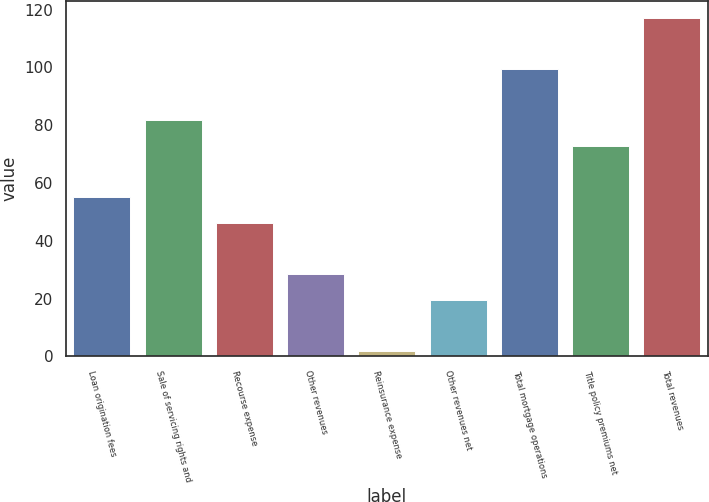<chart> <loc_0><loc_0><loc_500><loc_500><bar_chart><fcel>Loan origination fees<fcel>Sale of servicing rights and<fcel>Recourse expense<fcel>Other revenues<fcel>Reinsurance expense<fcel>Other revenues net<fcel>Total mortgage operations<fcel>Title policy premiums net<fcel>Total revenues<nl><fcel>55.06<fcel>81.64<fcel>46.2<fcel>28.48<fcel>1.9<fcel>19.62<fcel>99.36<fcel>72.78<fcel>117.08<nl></chart> 